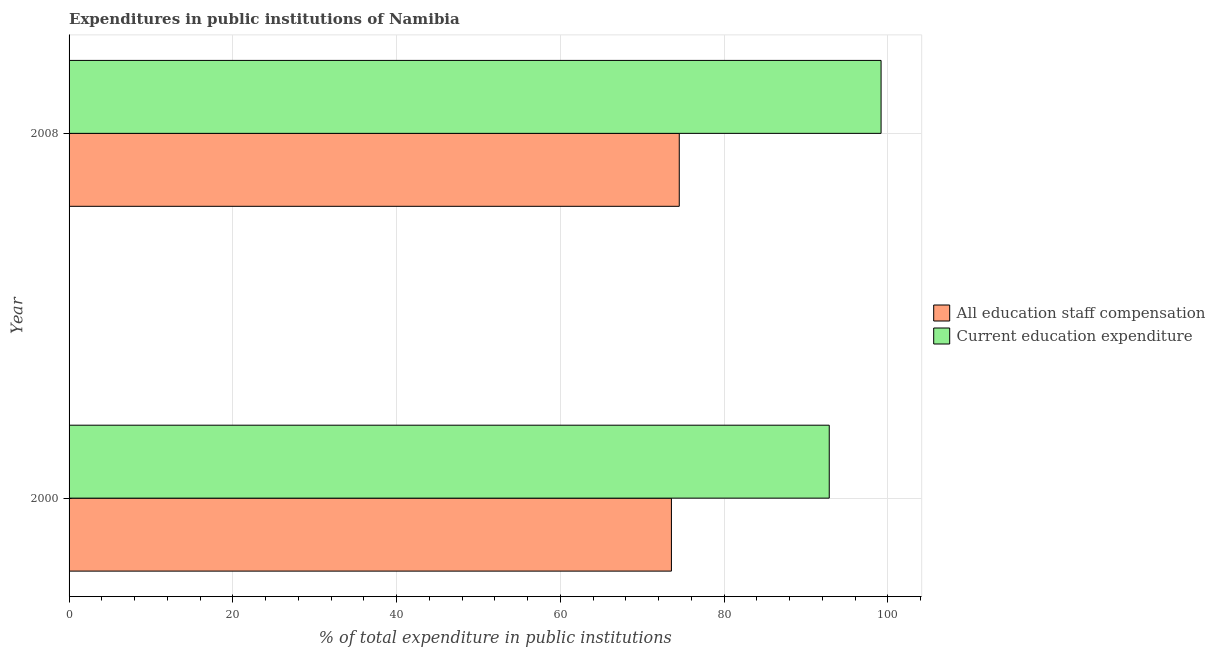Are the number of bars per tick equal to the number of legend labels?
Your answer should be very brief. Yes. Are the number of bars on each tick of the Y-axis equal?
Make the answer very short. Yes. How many bars are there on the 2nd tick from the top?
Offer a terse response. 2. How many bars are there on the 1st tick from the bottom?
Give a very brief answer. 2. What is the label of the 1st group of bars from the top?
Ensure brevity in your answer.  2008. In how many cases, is the number of bars for a given year not equal to the number of legend labels?
Provide a short and direct response. 0. What is the expenditure in education in 2000?
Keep it short and to the point. 92.84. Across all years, what is the maximum expenditure in staff compensation?
Make the answer very short. 74.52. Across all years, what is the minimum expenditure in education?
Offer a terse response. 92.84. In which year was the expenditure in education maximum?
Your answer should be compact. 2008. In which year was the expenditure in staff compensation minimum?
Offer a terse response. 2000. What is the total expenditure in staff compensation in the graph?
Give a very brief answer. 148.09. What is the difference between the expenditure in staff compensation in 2000 and that in 2008?
Give a very brief answer. -0.96. What is the difference between the expenditure in staff compensation in 2008 and the expenditure in education in 2000?
Your answer should be compact. -18.32. What is the average expenditure in staff compensation per year?
Provide a succinct answer. 74.04. In the year 2008, what is the difference between the expenditure in staff compensation and expenditure in education?
Ensure brevity in your answer.  -24.65. In how many years, is the expenditure in education greater than 88 %?
Give a very brief answer. 2. What is the ratio of the expenditure in education in 2000 to that in 2008?
Your answer should be compact. 0.94. In how many years, is the expenditure in education greater than the average expenditure in education taken over all years?
Offer a terse response. 1. What does the 2nd bar from the top in 2000 represents?
Your answer should be compact. All education staff compensation. What does the 2nd bar from the bottom in 2008 represents?
Offer a terse response. Current education expenditure. How many bars are there?
Provide a short and direct response. 4. Are all the bars in the graph horizontal?
Your response must be concise. Yes. Are the values on the major ticks of X-axis written in scientific E-notation?
Make the answer very short. No. Does the graph contain grids?
Your answer should be compact. Yes. How many legend labels are there?
Provide a succinct answer. 2. How are the legend labels stacked?
Offer a terse response. Vertical. What is the title of the graph?
Your response must be concise. Expenditures in public institutions of Namibia. What is the label or title of the X-axis?
Keep it short and to the point. % of total expenditure in public institutions. What is the % of total expenditure in public institutions in All education staff compensation in 2000?
Your answer should be compact. 73.56. What is the % of total expenditure in public institutions of Current education expenditure in 2000?
Give a very brief answer. 92.84. What is the % of total expenditure in public institutions of All education staff compensation in 2008?
Offer a very short reply. 74.52. What is the % of total expenditure in public institutions of Current education expenditure in 2008?
Provide a short and direct response. 99.17. Across all years, what is the maximum % of total expenditure in public institutions in All education staff compensation?
Your answer should be very brief. 74.52. Across all years, what is the maximum % of total expenditure in public institutions in Current education expenditure?
Provide a short and direct response. 99.17. Across all years, what is the minimum % of total expenditure in public institutions in All education staff compensation?
Provide a short and direct response. 73.56. Across all years, what is the minimum % of total expenditure in public institutions in Current education expenditure?
Make the answer very short. 92.84. What is the total % of total expenditure in public institutions in All education staff compensation in the graph?
Your answer should be compact. 148.09. What is the total % of total expenditure in public institutions in Current education expenditure in the graph?
Give a very brief answer. 192.01. What is the difference between the % of total expenditure in public institutions in All education staff compensation in 2000 and that in 2008?
Provide a short and direct response. -0.96. What is the difference between the % of total expenditure in public institutions in Current education expenditure in 2000 and that in 2008?
Offer a very short reply. -6.33. What is the difference between the % of total expenditure in public institutions of All education staff compensation in 2000 and the % of total expenditure in public institutions of Current education expenditure in 2008?
Your answer should be very brief. -25.61. What is the average % of total expenditure in public institutions in All education staff compensation per year?
Provide a succinct answer. 74.04. What is the average % of total expenditure in public institutions of Current education expenditure per year?
Your response must be concise. 96. In the year 2000, what is the difference between the % of total expenditure in public institutions of All education staff compensation and % of total expenditure in public institutions of Current education expenditure?
Offer a very short reply. -19.28. In the year 2008, what is the difference between the % of total expenditure in public institutions in All education staff compensation and % of total expenditure in public institutions in Current education expenditure?
Make the answer very short. -24.65. What is the ratio of the % of total expenditure in public institutions of All education staff compensation in 2000 to that in 2008?
Offer a very short reply. 0.99. What is the ratio of the % of total expenditure in public institutions in Current education expenditure in 2000 to that in 2008?
Make the answer very short. 0.94. What is the difference between the highest and the second highest % of total expenditure in public institutions in All education staff compensation?
Make the answer very short. 0.96. What is the difference between the highest and the second highest % of total expenditure in public institutions of Current education expenditure?
Your answer should be compact. 6.33. What is the difference between the highest and the lowest % of total expenditure in public institutions of All education staff compensation?
Ensure brevity in your answer.  0.96. What is the difference between the highest and the lowest % of total expenditure in public institutions in Current education expenditure?
Provide a short and direct response. 6.33. 